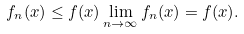<formula> <loc_0><loc_0><loc_500><loc_500>f _ { n } ( x ) \leq f ( x ) \lim _ { n \to \infty } f _ { n } ( x ) = f ( x ) .</formula> 